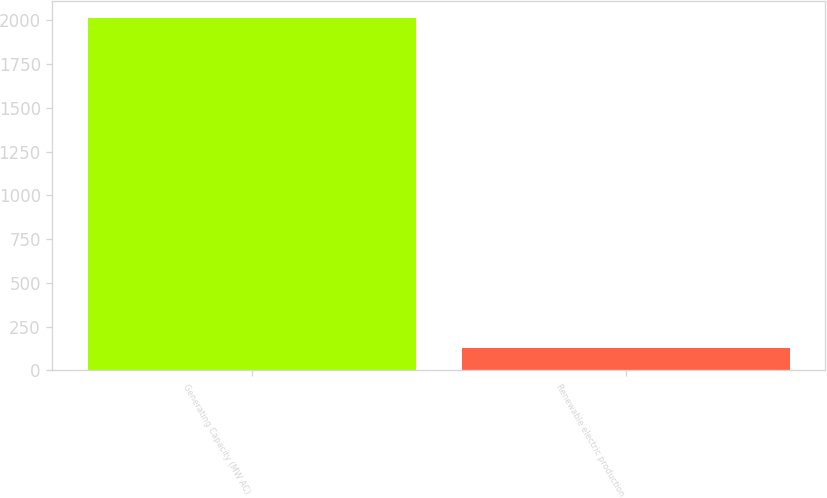Convert chart. <chart><loc_0><loc_0><loc_500><loc_500><bar_chart><fcel>Generating Capacity (MW AC)<fcel>Renewable electric production<nl><fcel>2012<fcel>127<nl></chart> 